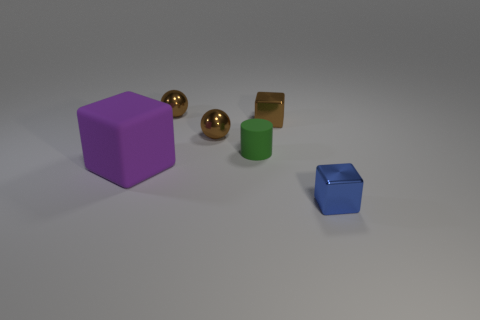Could you create a short story based on these objects? In a quiet room illuminated by a single spotlight, the colorful shapes come to life each night. The purple cube, known as the wise one, governs the laws of their small universe. Two golden orbs, the twin explorers, circle around, always in search of hidden treasures within the corners of their limited cosmos. The green cylinder, the thinker, reflects on the mysteries of shape, while the small blue cube, the youngest, looks up to the others, brimming with curiosity. Together, these objects share a silent harmony, existing somewhere between the stillness of reality and the vibrant pulse of imagination. 